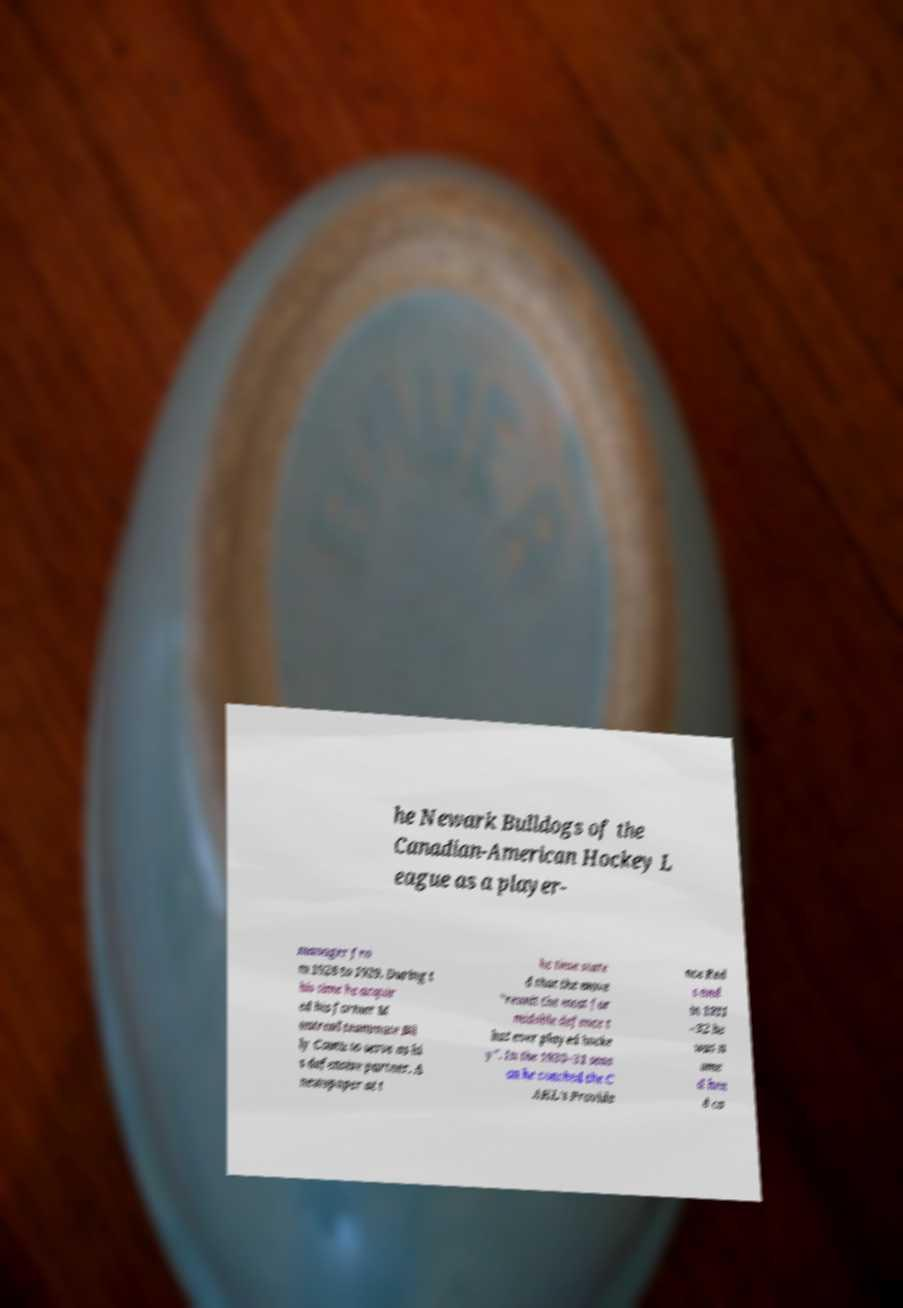Please read and relay the text visible in this image. What does it say? he Newark Bulldogs of the Canadian-American Hockey L eague as a player- manager fro m 1928 to 1929. During t his time he acquir ed his former M ontreal teammate Bil ly Coutu to serve as hi s defensive partner. A newspaper at t he time state d that the move "reunit the most for midable defence t hat ever played hocke y". In the 1930–31 seas on he coached the C AHL's Provide nce Red s and in 1931 –32 he was n ame d hea d co 